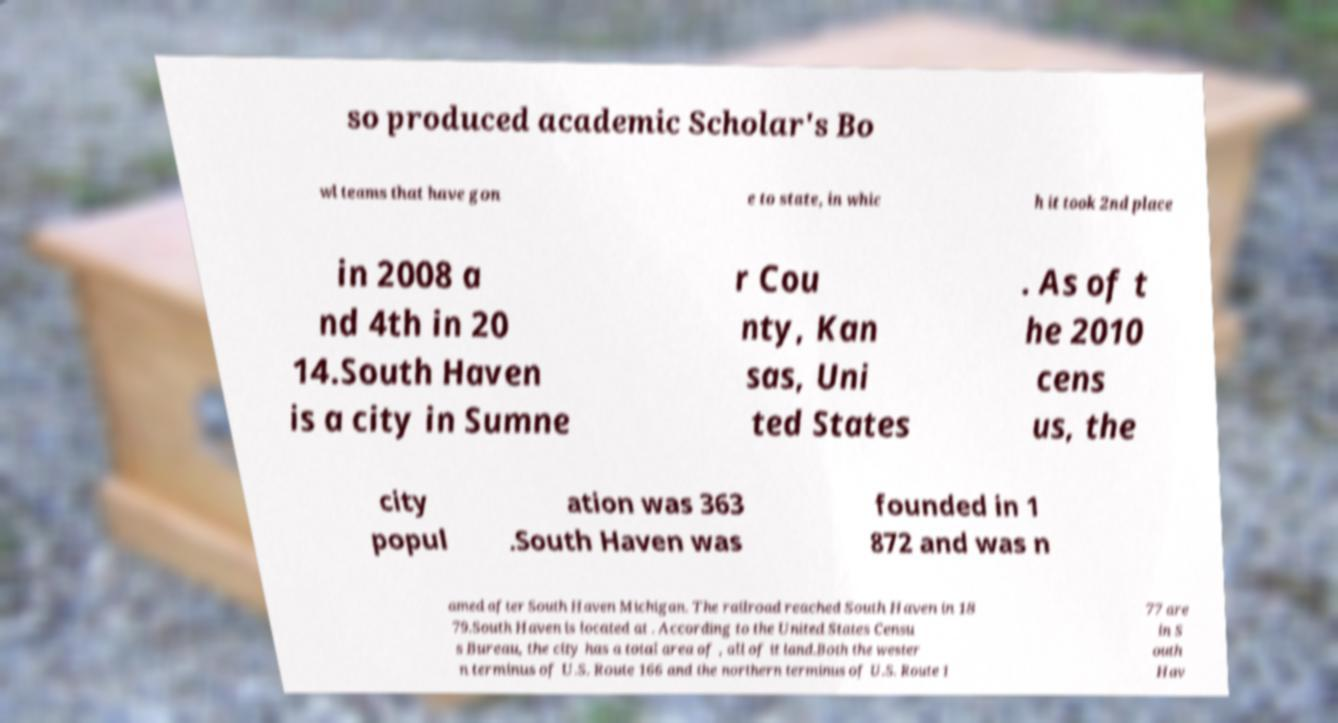Can you read and provide the text displayed in the image?This photo seems to have some interesting text. Can you extract and type it out for me? so produced academic Scholar's Bo wl teams that have gon e to state, in whic h it took 2nd place in 2008 a nd 4th in 20 14.South Haven is a city in Sumne r Cou nty, Kan sas, Uni ted States . As of t he 2010 cens us, the city popul ation was 363 .South Haven was founded in 1 872 and was n amed after South Haven Michigan. The railroad reached South Haven in 18 79.South Haven is located at . According to the United States Censu s Bureau, the city has a total area of , all of it land.Both the wester n terminus of U.S. Route 166 and the northern terminus of U.S. Route 1 77 are in S outh Hav 